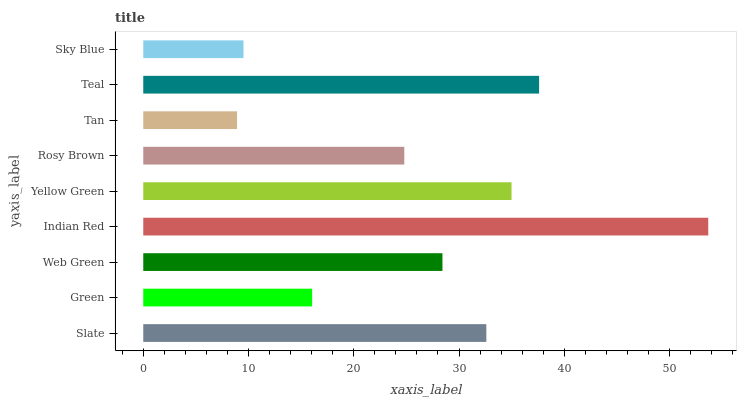Is Tan the minimum?
Answer yes or no. Yes. Is Indian Red the maximum?
Answer yes or no. Yes. Is Green the minimum?
Answer yes or no. No. Is Green the maximum?
Answer yes or no. No. Is Slate greater than Green?
Answer yes or no. Yes. Is Green less than Slate?
Answer yes or no. Yes. Is Green greater than Slate?
Answer yes or no. No. Is Slate less than Green?
Answer yes or no. No. Is Web Green the high median?
Answer yes or no. Yes. Is Web Green the low median?
Answer yes or no. Yes. Is Slate the high median?
Answer yes or no. No. Is Green the low median?
Answer yes or no. No. 